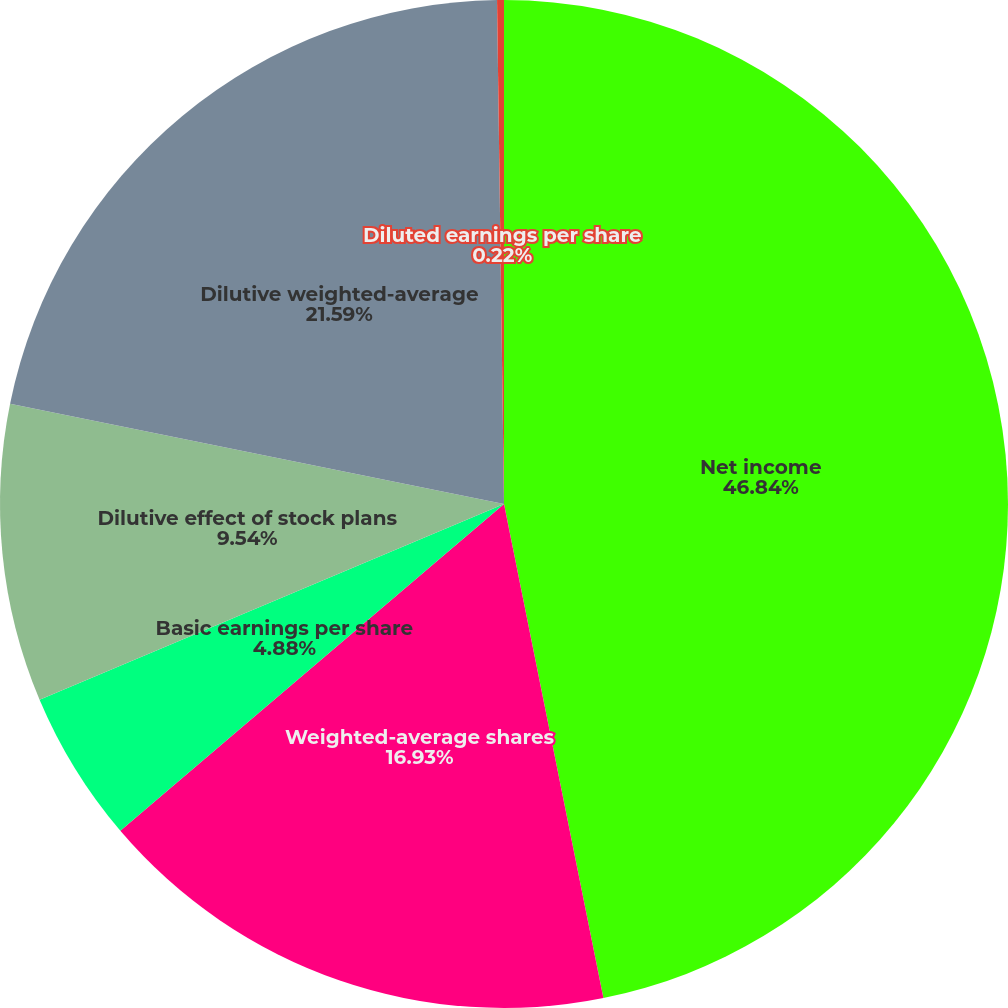<chart> <loc_0><loc_0><loc_500><loc_500><pie_chart><fcel>Net income<fcel>Weighted-average shares<fcel>Basic earnings per share<fcel>Dilutive effect of stock plans<fcel>Dilutive weighted-average<fcel>Diluted earnings per share<nl><fcel>46.84%<fcel>16.93%<fcel>4.88%<fcel>9.54%<fcel>21.59%<fcel>0.22%<nl></chart> 